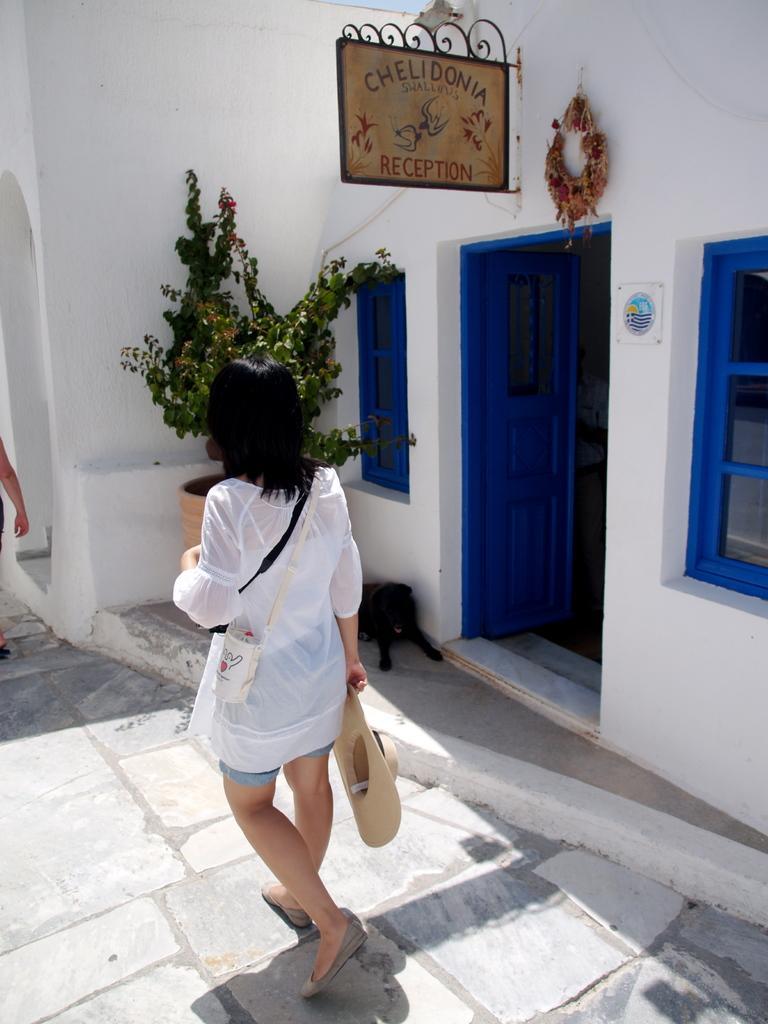Describe this image in one or two sentences. In this picture we can see a woman is walking and holding a cap, on the right side there is a house, we can see a board and a plant in the middle, on the left side there is another person, we can see windows and a door of this house. 